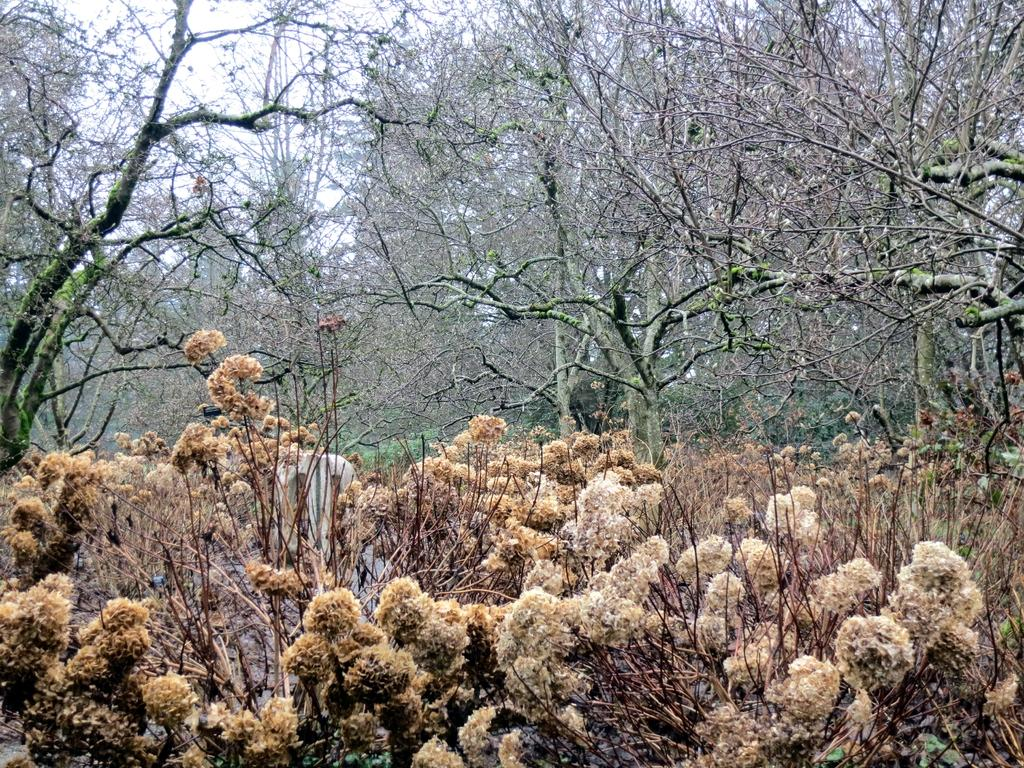What types of vegetation can be seen at the bottom of the image? There are plants and flowers at the bottom of the image. What can be seen in the background of the image? There are trees in the background of the image. What is visible at the top of the image? The sky is visible at the top of the image. Where is the amusement park located in the image? There is no amusement park present in the image. What type of coach can be seen driving through the trees in the image? There is no coach or any vehicles visible in the image; only plants, flowers, trees, and the sky are present. 